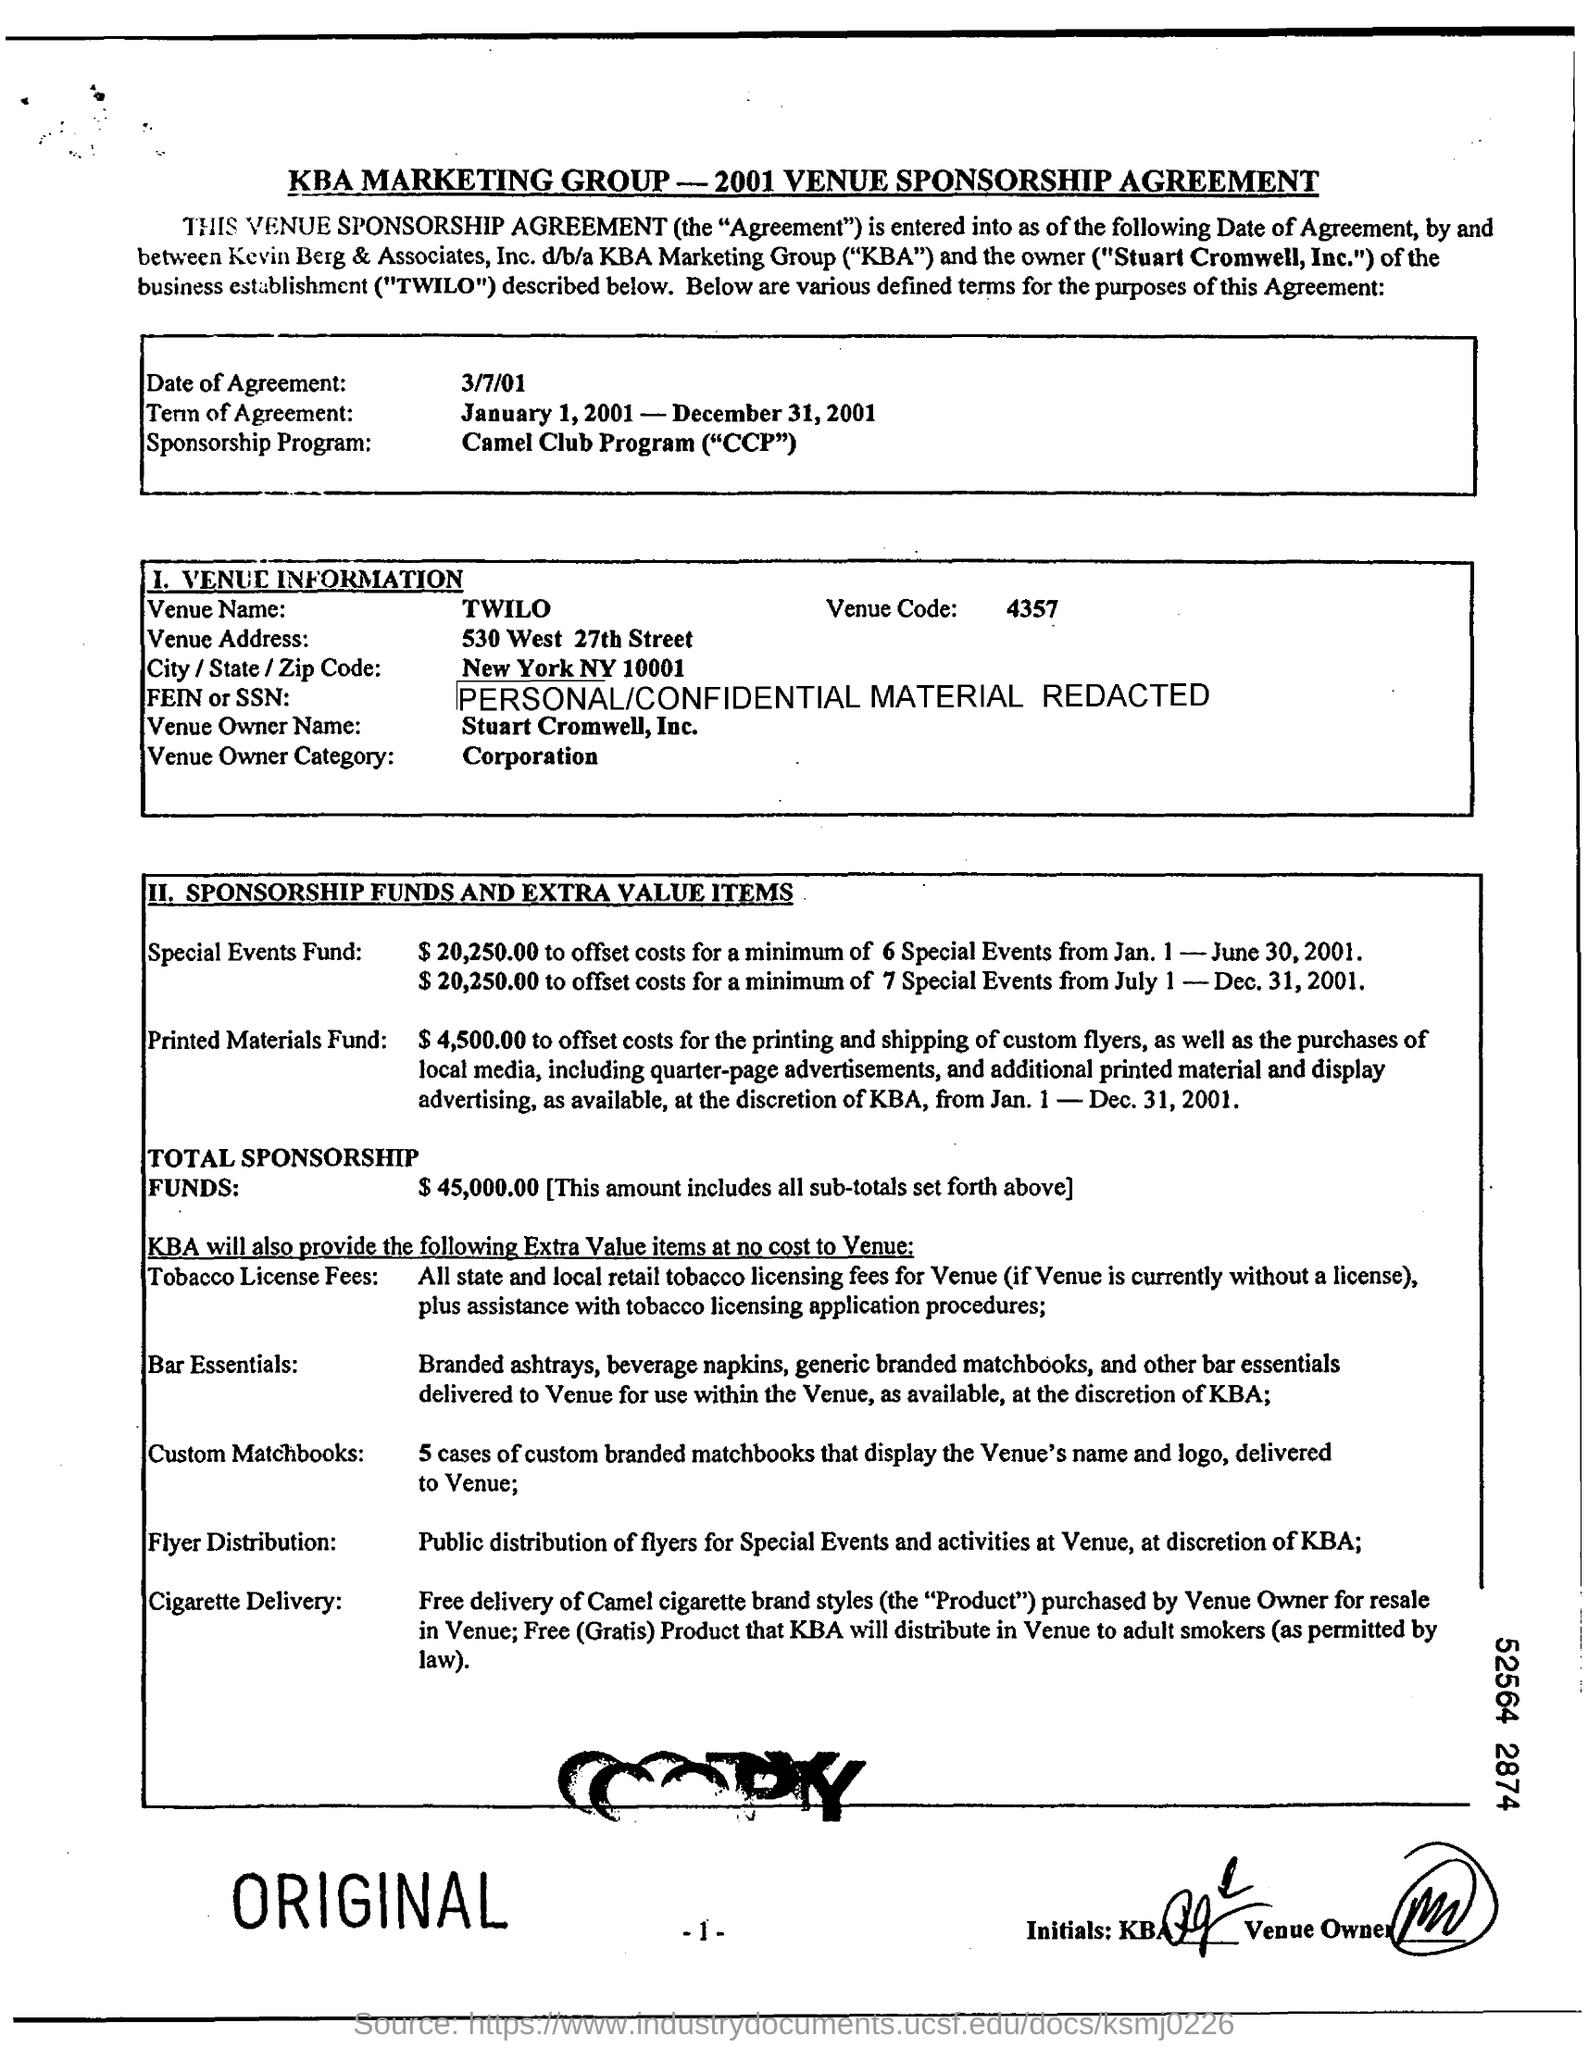what is the venue name ? The venue name is TWILO, located at 530 West 27th Street, New York NY 10001. It appears to be involved in a Venue Sponsorship Agreement with KBA Marketing Group, as part of their Camel Club Program. 